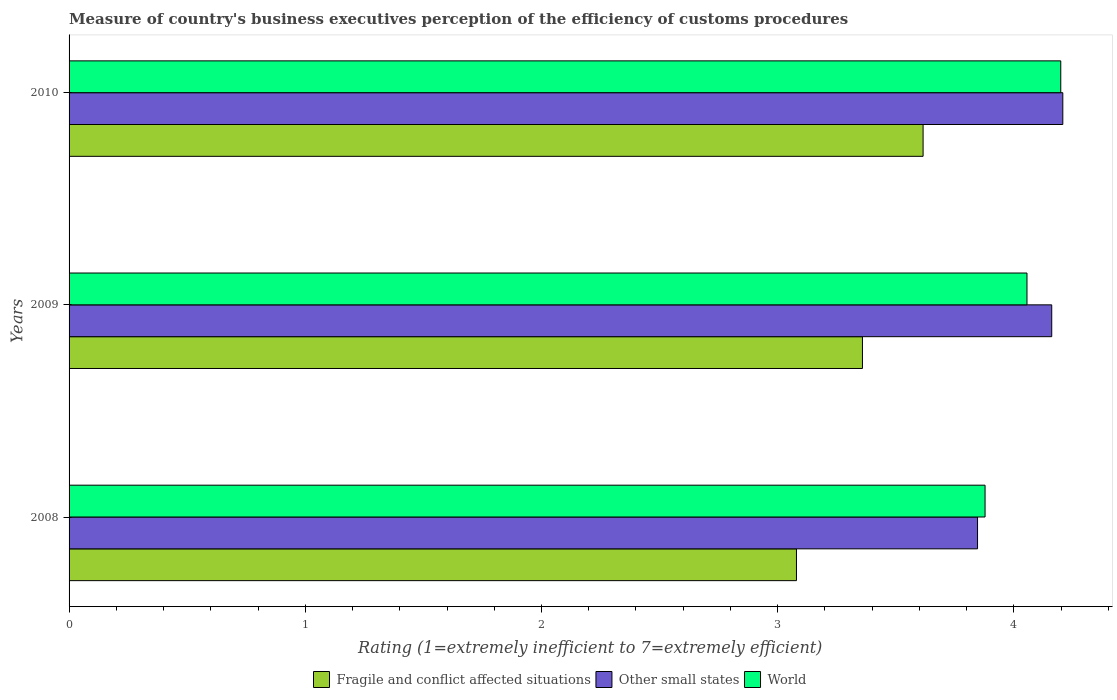How many different coloured bars are there?
Offer a terse response. 3. How many groups of bars are there?
Provide a short and direct response. 3. Are the number of bars per tick equal to the number of legend labels?
Keep it short and to the point. Yes. In how many cases, is the number of bars for a given year not equal to the number of legend labels?
Give a very brief answer. 0. What is the rating of the efficiency of customs procedure in Fragile and conflict affected situations in 2009?
Ensure brevity in your answer.  3.36. Across all years, what is the maximum rating of the efficiency of customs procedure in Fragile and conflict affected situations?
Provide a short and direct response. 3.62. Across all years, what is the minimum rating of the efficiency of customs procedure in World?
Your response must be concise. 3.88. In which year was the rating of the efficiency of customs procedure in Other small states minimum?
Provide a succinct answer. 2008. What is the total rating of the efficiency of customs procedure in Other small states in the graph?
Provide a short and direct response. 12.21. What is the difference between the rating of the efficiency of customs procedure in World in 2009 and that in 2010?
Offer a very short reply. -0.14. What is the difference between the rating of the efficiency of customs procedure in World in 2010 and the rating of the efficiency of customs procedure in Fragile and conflict affected situations in 2008?
Your answer should be compact. 1.12. What is the average rating of the efficiency of customs procedure in Other small states per year?
Make the answer very short. 4.07. In the year 2009, what is the difference between the rating of the efficiency of customs procedure in Fragile and conflict affected situations and rating of the efficiency of customs procedure in Other small states?
Keep it short and to the point. -0.8. In how many years, is the rating of the efficiency of customs procedure in Fragile and conflict affected situations greater than 1 ?
Provide a short and direct response. 3. What is the ratio of the rating of the efficiency of customs procedure in World in 2008 to that in 2010?
Your response must be concise. 0.92. Is the difference between the rating of the efficiency of customs procedure in Fragile and conflict affected situations in 2009 and 2010 greater than the difference between the rating of the efficiency of customs procedure in Other small states in 2009 and 2010?
Your answer should be compact. No. What is the difference between the highest and the second highest rating of the efficiency of customs procedure in Fragile and conflict affected situations?
Your answer should be very brief. 0.26. What is the difference between the highest and the lowest rating of the efficiency of customs procedure in World?
Offer a terse response. 0.32. In how many years, is the rating of the efficiency of customs procedure in World greater than the average rating of the efficiency of customs procedure in World taken over all years?
Give a very brief answer. 2. What does the 1st bar from the bottom in 2008 represents?
Provide a short and direct response. Fragile and conflict affected situations. Is it the case that in every year, the sum of the rating of the efficiency of customs procedure in Fragile and conflict affected situations and rating of the efficiency of customs procedure in World is greater than the rating of the efficiency of customs procedure in Other small states?
Your response must be concise. Yes. How many years are there in the graph?
Provide a short and direct response. 3. What is the difference between two consecutive major ticks on the X-axis?
Keep it short and to the point. 1. Does the graph contain any zero values?
Give a very brief answer. No. Does the graph contain grids?
Provide a succinct answer. No. What is the title of the graph?
Your answer should be compact. Measure of country's business executives perception of the efficiency of customs procedures. What is the label or title of the X-axis?
Your answer should be compact. Rating (1=extremely inefficient to 7=extremely efficient). What is the label or title of the Y-axis?
Your answer should be very brief. Years. What is the Rating (1=extremely inefficient to 7=extremely efficient) in Fragile and conflict affected situations in 2008?
Give a very brief answer. 3.08. What is the Rating (1=extremely inefficient to 7=extremely efficient) of Other small states in 2008?
Your response must be concise. 3.85. What is the Rating (1=extremely inefficient to 7=extremely efficient) in World in 2008?
Your answer should be very brief. 3.88. What is the Rating (1=extremely inefficient to 7=extremely efficient) of Fragile and conflict affected situations in 2009?
Offer a terse response. 3.36. What is the Rating (1=extremely inefficient to 7=extremely efficient) in Other small states in 2009?
Your response must be concise. 4.16. What is the Rating (1=extremely inefficient to 7=extremely efficient) in World in 2009?
Offer a terse response. 4.06. What is the Rating (1=extremely inefficient to 7=extremely efficient) in Fragile and conflict affected situations in 2010?
Give a very brief answer. 3.62. What is the Rating (1=extremely inefficient to 7=extremely efficient) of Other small states in 2010?
Provide a succinct answer. 4.21. What is the Rating (1=extremely inefficient to 7=extremely efficient) in World in 2010?
Provide a succinct answer. 4.2. Across all years, what is the maximum Rating (1=extremely inefficient to 7=extremely efficient) in Fragile and conflict affected situations?
Your answer should be very brief. 3.62. Across all years, what is the maximum Rating (1=extremely inefficient to 7=extremely efficient) of Other small states?
Your answer should be compact. 4.21. Across all years, what is the maximum Rating (1=extremely inefficient to 7=extremely efficient) of World?
Your answer should be compact. 4.2. Across all years, what is the minimum Rating (1=extremely inefficient to 7=extremely efficient) of Fragile and conflict affected situations?
Your answer should be compact. 3.08. Across all years, what is the minimum Rating (1=extremely inefficient to 7=extremely efficient) of Other small states?
Keep it short and to the point. 3.85. Across all years, what is the minimum Rating (1=extremely inefficient to 7=extremely efficient) in World?
Provide a short and direct response. 3.88. What is the total Rating (1=extremely inefficient to 7=extremely efficient) of Fragile and conflict affected situations in the graph?
Provide a short and direct response. 10.05. What is the total Rating (1=extremely inefficient to 7=extremely efficient) of Other small states in the graph?
Ensure brevity in your answer.  12.21. What is the total Rating (1=extremely inefficient to 7=extremely efficient) of World in the graph?
Keep it short and to the point. 12.13. What is the difference between the Rating (1=extremely inefficient to 7=extremely efficient) in Fragile and conflict affected situations in 2008 and that in 2009?
Give a very brief answer. -0.28. What is the difference between the Rating (1=extremely inefficient to 7=extremely efficient) of Other small states in 2008 and that in 2009?
Provide a succinct answer. -0.31. What is the difference between the Rating (1=extremely inefficient to 7=extremely efficient) of World in 2008 and that in 2009?
Keep it short and to the point. -0.18. What is the difference between the Rating (1=extremely inefficient to 7=extremely efficient) of Fragile and conflict affected situations in 2008 and that in 2010?
Provide a succinct answer. -0.54. What is the difference between the Rating (1=extremely inefficient to 7=extremely efficient) in Other small states in 2008 and that in 2010?
Make the answer very short. -0.36. What is the difference between the Rating (1=extremely inefficient to 7=extremely efficient) of World in 2008 and that in 2010?
Your answer should be compact. -0.32. What is the difference between the Rating (1=extremely inefficient to 7=extremely efficient) in Fragile and conflict affected situations in 2009 and that in 2010?
Make the answer very short. -0.26. What is the difference between the Rating (1=extremely inefficient to 7=extremely efficient) in Other small states in 2009 and that in 2010?
Your response must be concise. -0.05. What is the difference between the Rating (1=extremely inefficient to 7=extremely efficient) in World in 2009 and that in 2010?
Your answer should be compact. -0.14. What is the difference between the Rating (1=extremely inefficient to 7=extremely efficient) of Fragile and conflict affected situations in 2008 and the Rating (1=extremely inefficient to 7=extremely efficient) of Other small states in 2009?
Offer a very short reply. -1.08. What is the difference between the Rating (1=extremely inefficient to 7=extremely efficient) in Fragile and conflict affected situations in 2008 and the Rating (1=extremely inefficient to 7=extremely efficient) in World in 2009?
Your answer should be compact. -0.98. What is the difference between the Rating (1=extremely inefficient to 7=extremely efficient) of Other small states in 2008 and the Rating (1=extremely inefficient to 7=extremely efficient) of World in 2009?
Offer a terse response. -0.21. What is the difference between the Rating (1=extremely inefficient to 7=extremely efficient) in Fragile and conflict affected situations in 2008 and the Rating (1=extremely inefficient to 7=extremely efficient) in Other small states in 2010?
Give a very brief answer. -1.13. What is the difference between the Rating (1=extremely inefficient to 7=extremely efficient) of Fragile and conflict affected situations in 2008 and the Rating (1=extremely inefficient to 7=extremely efficient) of World in 2010?
Offer a very short reply. -1.12. What is the difference between the Rating (1=extremely inefficient to 7=extremely efficient) of Other small states in 2008 and the Rating (1=extremely inefficient to 7=extremely efficient) of World in 2010?
Make the answer very short. -0.35. What is the difference between the Rating (1=extremely inefficient to 7=extremely efficient) in Fragile and conflict affected situations in 2009 and the Rating (1=extremely inefficient to 7=extremely efficient) in Other small states in 2010?
Your answer should be very brief. -0.85. What is the difference between the Rating (1=extremely inefficient to 7=extremely efficient) in Fragile and conflict affected situations in 2009 and the Rating (1=extremely inefficient to 7=extremely efficient) in World in 2010?
Make the answer very short. -0.84. What is the difference between the Rating (1=extremely inefficient to 7=extremely efficient) in Other small states in 2009 and the Rating (1=extremely inefficient to 7=extremely efficient) in World in 2010?
Provide a short and direct response. -0.04. What is the average Rating (1=extremely inefficient to 7=extremely efficient) of Fragile and conflict affected situations per year?
Keep it short and to the point. 3.35. What is the average Rating (1=extremely inefficient to 7=extremely efficient) in Other small states per year?
Your response must be concise. 4.07. What is the average Rating (1=extremely inefficient to 7=extremely efficient) in World per year?
Your answer should be very brief. 4.04. In the year 2008, what is the difference between the Rating (1=extremely inefficient to 7=extremely efficient) of Fragile and conflict affected situations and Rating (1=extremely inefficient to 7=extremely efficient) of Other small states?
Offer a terse response. -0.77. In the year 2008, what is the difference between the Rating (1=extremely inefficient to 7=extremely efficient) in Fragile and conflict affected situations and Rating (1=extremely inefficient to 7=extremely efficient) in World?
Your answer should be very brief. -0.8. In the year 2008, what is the difference between the Rating (1=extremely inefficient to 7=extremely efficient) of Other small states and Rating (1=extremely inefficient to 7=extremely efficient) of World?
Make the answer very short. -0.03. In the year 2009, what is the difference between the Rating (1=extremely inefficient to 7=extremely efficient) of Fragile and conflict affected situations and Rating (1=extremely inefficient to 7=extremely efficient) of Other small states?
Offer a very short reply. -0.8. In the year 2009, what is the difference between the Rating (1=extremely inefficient to 7=extremely efficient) in Fragile and conflict affected situations and Rating (1=extremely inefficient to 7=extremely efficient) in World?
Your answer should be very brief. -0.7. In the year 2009, what is the difference between the Rating (1=extremely inefficient to 7=extremely efficient) of Other small states and Rating (1=extremely inefficient to 7=extremely efficient) of World?
Your answer should be compact. 0.1. In the year 2010, what is the difference between the Rating (1=extremely inefficient to 7=extremely efficient) of Fragile and conflict affected situations and Rating (1=extremely inefficient to 7=extremely efficient) of Other small states?
Give a very brief answer. -0.59. In the year 2010, what is the difference between the Rating (1=extremely inefficient to 7=extremely efficient) in Fragile and conflict affected situations and Rating (1=extremely inefficient to 7=extremely efficient) in World?
Your response must be concise. -0.58. In the year 2010, what is the difference between the Rating (1=extremely inefficient to 7=extremely efficient) in Other small states and Rating (1=extremely inefficient to 7=extremely efficient) in World?
Provide a succinct answer. 0.01. What is the ratio of the Rating (1=extremely inefficient to 7=extremely efficient) of Fragile and conflict affected situations in 2008 to that in 2009?
Offer a terse response. 0.92. What is the ratio of the Rating (1=extremely inefficient to 7=extremely efficient) in Other small states in 2008 to that in 2009?
Your answer should be very brief. 0.92. What is the ratio of the Rating (1=extremely inefficient to 7=extremely efficient) in World in 2008 to that in 2009?
Offer a terse response. 0.96. What is the ratio of the Rating (1=extremely inefficient to 7=extremely efficient) of Fragile and conflict affected situations in 2008 to that in 2010?
Provide a short and direct response. 0.85. What is the ratio of the Rating (1=extremely inefficient to 7=extremely efficient) in Other small states in 2008 to that in 2010?
Your answer should be compact. 0.91. What is the ratio of the Rating (1=extremely inefficient to 7=extremely efficient) in World in 2008 to that in 2010?
Offer a terse response. 0.92. What is the ratio of the Rating (1=extremely inefficient to 7=extremely efficient) in Fragile and conflict affected situations in 2009 to that in 2010?
Your answer should be compact. 0.93. What is the ratio of the Rating (1=extremely inefficient to 7=extremely efficient) in Other small states in 2009 to that in 2010?
Ensure brevity in your answer.  0.99. What is the ratio of the Rating (1=extremely inefficient to 7=extremely efficient) of World in 2009 to that in 2010?
Your response must be concise. 0.97. What is the difference between the highest and the second highest Rating (1=extremely inefficient to 7=extremely efficient) in Fragile and conflict affected situations?
Offer a terse response. 0.26. What is the difference between the highest and the second highest Rating (1=extremely inefficient to 7=extremely efficient) of Other small states?
Give a very brief answer. 0.05. What is the difference between the highest and the second highest Rating (1=extremely inefficient to 7=extremely efficient) in World?
Make the answer very short. 0.14. What is the difference between the highest and the lowest Rating (1=extremely inefficient to 7=extremely efficient) in Fragile and conflict affected situations?
Provide a succinct answer. 0.54. What is the difference between the highest and the lowest Rating (1=extremely inefficient to 7=extremely efficient) of Other small states?
Provide a short and direct response. 0.36. What is the difference between the highest and the lowest Rating (1=extremely inefficient to 7=extremely efficient) in World?
Keep it short and to the point. 0.32. 